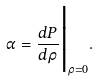<formula> <loc_0><loc_0><loc_500><loc_500>\alpha = \frac { d P } { d \rho } \Big | _ { \rho = 0 } .</formula> 